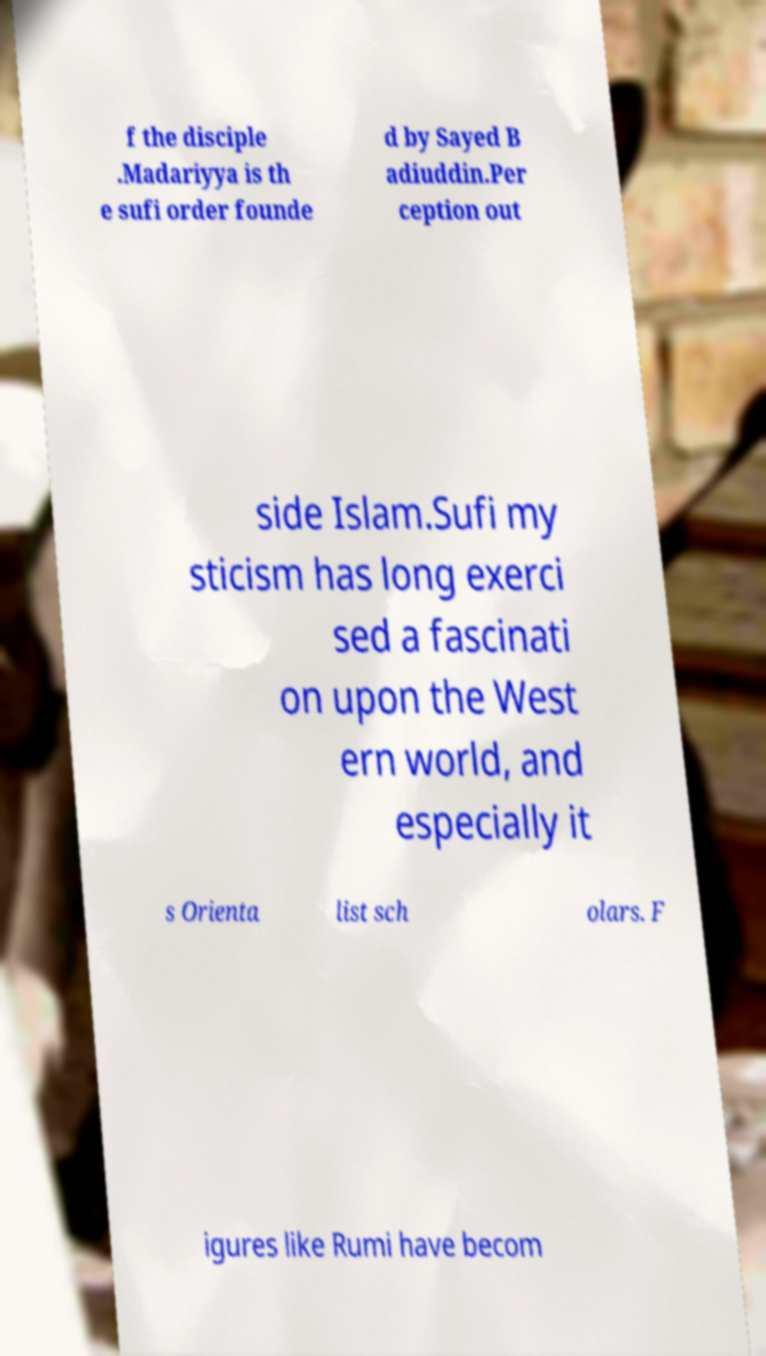Could you extract and type out the text from this image? f the disciple .Madariyya is th e sufi order founde d by Sayed B adiuddin.Per ception out side Islam.Sufi my sticism has long exerci sed a fascinati on upon the West ern world, and especially it s Orienta list sch olars. F igures like Rumi have becom 